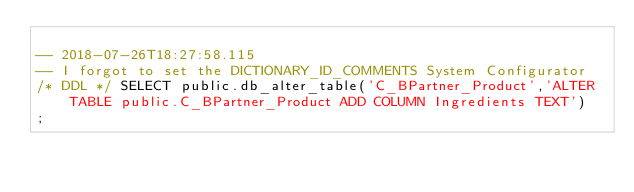<code> <loc_0><loc_0><loc_500><loc_500><_SQL_>
-- 2018-07-26T18:27:58.115
-- I forgot to set the DICTIONARY_ID_COMMENTS System Configurator
/* DDL */ SELECT public.db_alter_table('C_BPartner_Product','ALTER TABLE public.C_BPartner_Product ADD COLUMN Ingredients TEXT')
;
</code> 